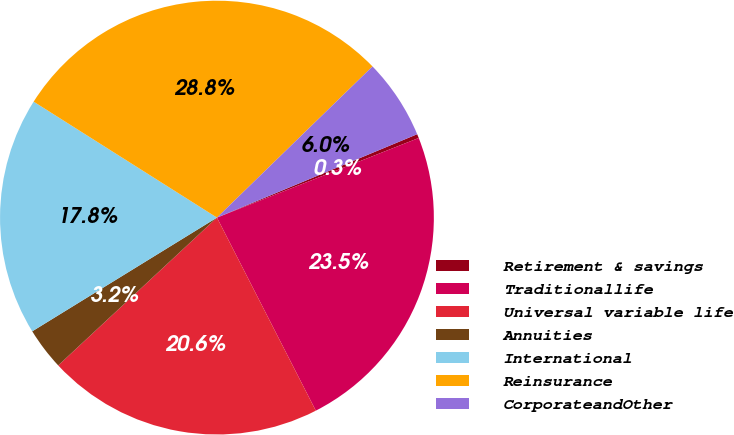Convert chart to OTSL. <chart><loc_0><loc_0><loc_500><loc_500><pie_chart><fcel>Retirement & savings<fcel>Traditionallife<fcel>Universal variable life<fcel>Annuities<fcel>International<fcel>Reinsurance<fcel>CorporateandOther<nl><fcel>0.3%<fcel>23.45%<fcel>20.6%<fcel>3.15%<fcel>17.76%<fcel>28.75%<fcel>5.99%<nl></chart> 